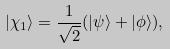<formula> <loc_0><loc_0><loc_500><loc_500>| \chi _ { 1 } \rangle = \frac { 1 } { \sqrt { 2 } } ( | \psi \rangle + | \phi \rangle ) ,</formula> 